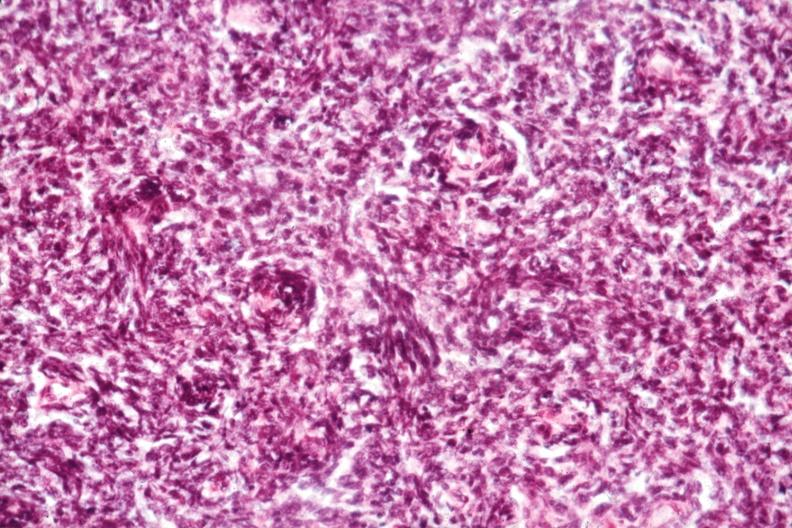what is present?
Answer the question using a single word or phrase. Thymus 